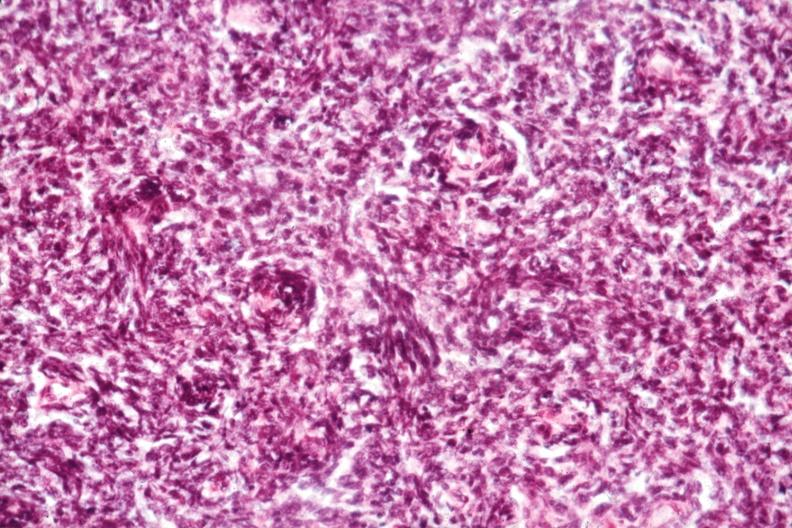what is present?
Answer the question using a single word or phrase. Thymus 